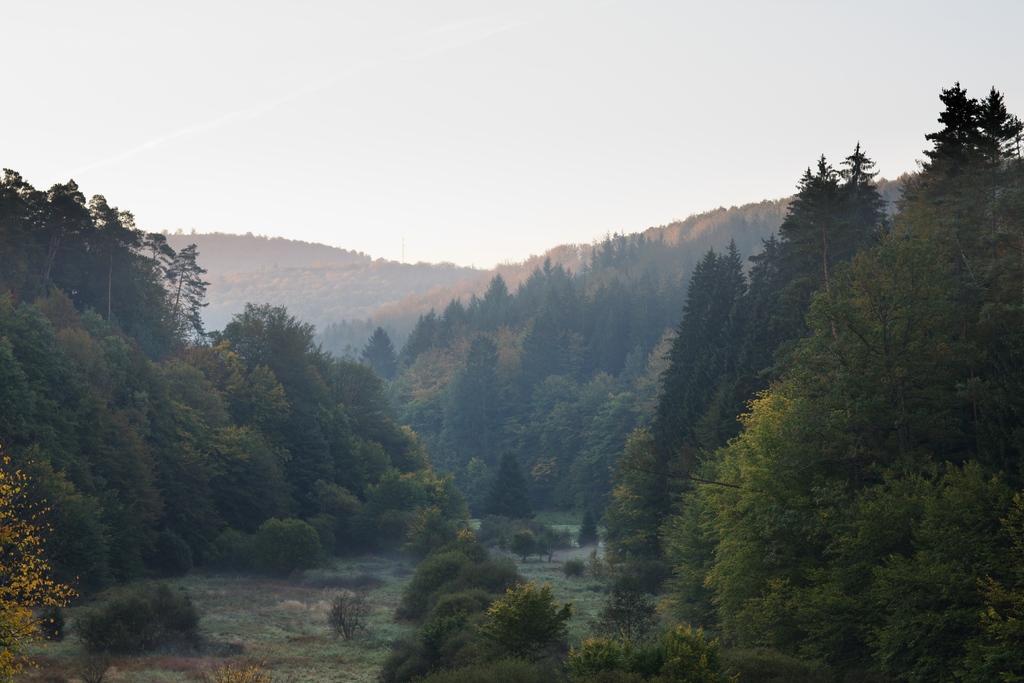Describe this image in one or two sentences. In this picture I can see there is the land in the middle and trees on either side of the land. And the background is the sky. 